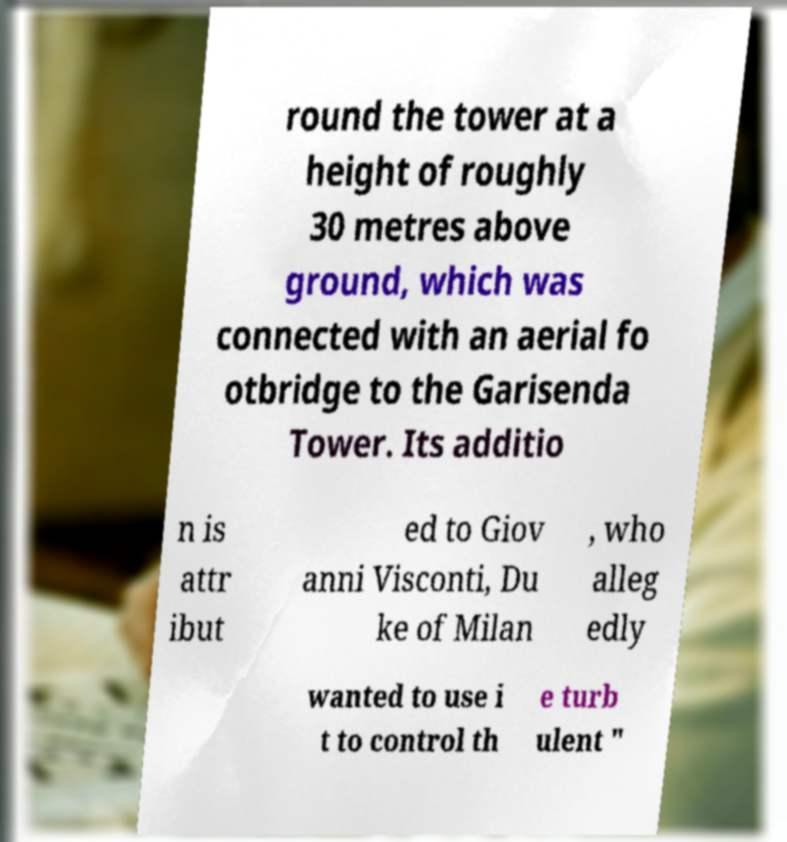There's text embedded in this image that I need extracted. Can you transcribe it verbatim? round the tower at a height of roughly 30 metres above ground, which was connected with an aerial fo otbridge to the Garisenda Tower. Its additio n is attr ibut ed to Giov anni Visconti, Du ke of Milan , who alleg edly wanted to use i t to control th e turb ulent " 